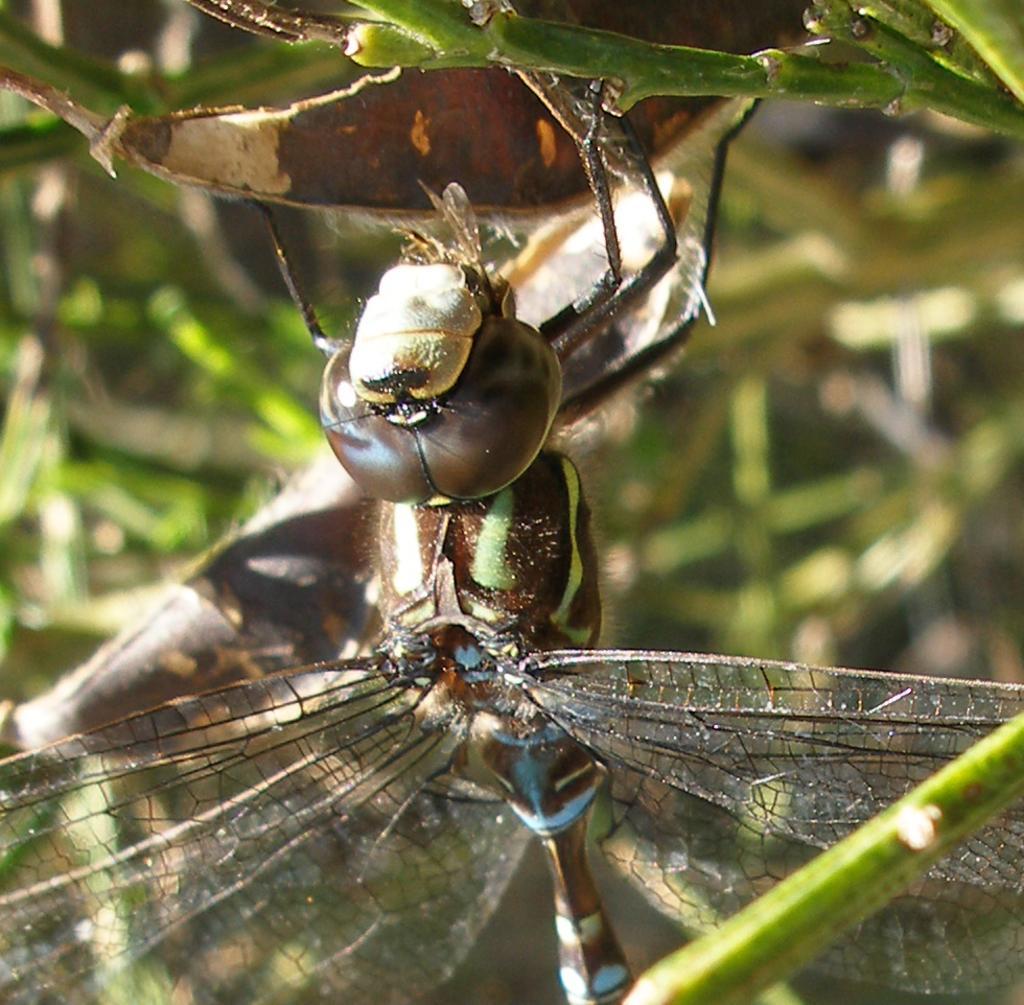Please provide a concise description of this image. This image is taken outdoors. In the background there is a plant. In the middle of the image there is a dragonfly on the leaf. 